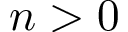Convert formula to latex. <formula><loc_0><loc_0><loc_500><loc_500>n > 0</formula> 